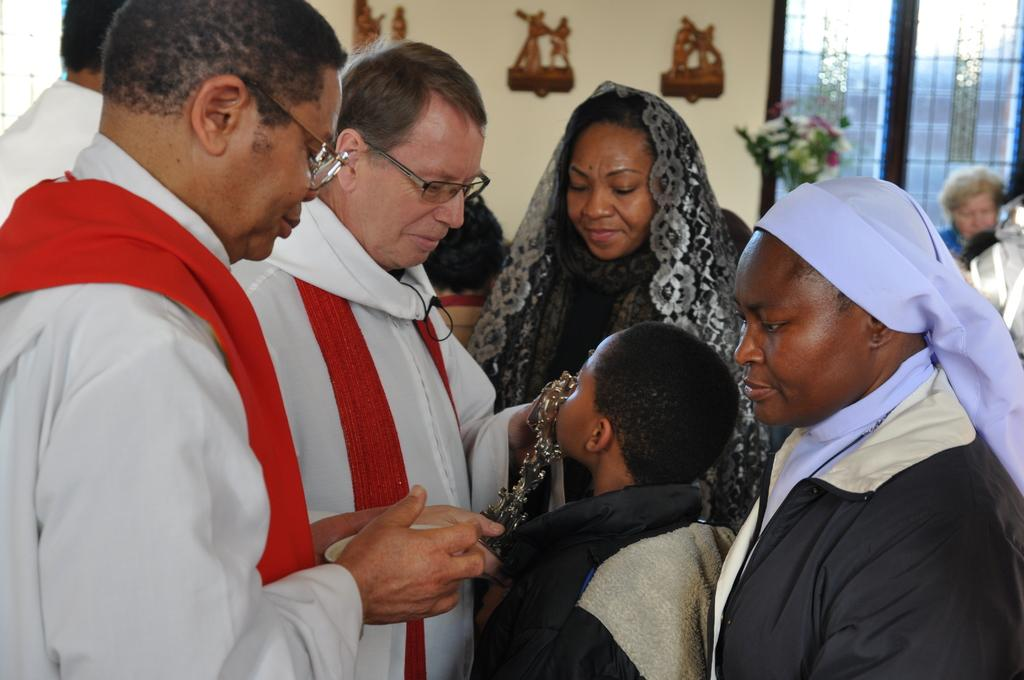What is happening in the front of the image? There is a group of persons standing in the front of the image. What can be seen in the background of the image? There is a flower bouquet, a wall, frames, and a window in the background of the image. What type of industry is depicted in the image? There is no industry depicted in the image; it features a group of persons standing in the front and various elements in the background. How many turkeys are present in the image? There are no turkeys present in the image. 